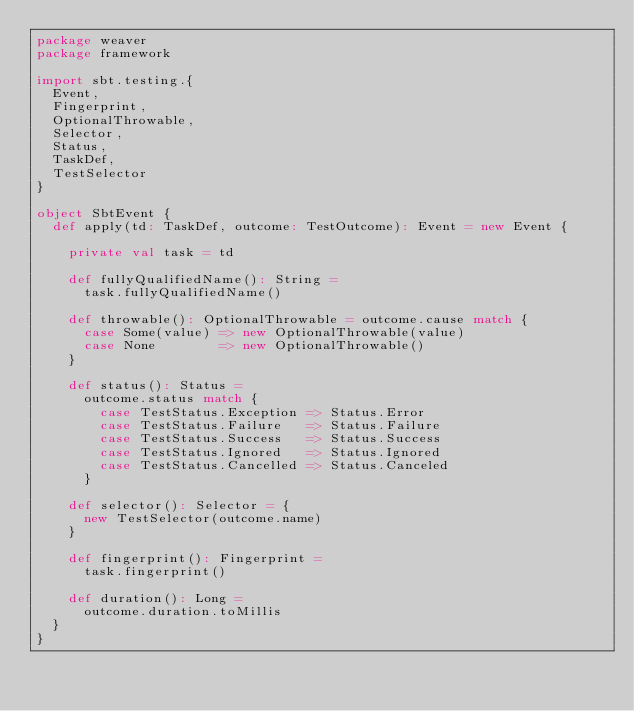<code> <loc_0><loc_0><loc_500><loc_500><_Scala_>package weaver
package framework

import sbt.testing.{
  Event,
  Fingerprint,
  OptionalThrowable,
  Selector,
  Status,
  TaskDef,
  TestSelector
}

object SbtEvent {
  def apply(td: TaskDef, outcome: TestOutcome): Event = new Event {

    private val task = td

    def fullyQualifiedName(): String =
      task.fullyQualifiedName()

    def throwable(): OptionalThrowable = outcome.cause match {
      case Some(value) => new OptionalThrowable(value)
      case None        => new OptionalThrowable()
    }

    def status(): Status =
      outcome.status match {
        case TestStatus.Exception => Status.Error
        case TestStatus.Failure   => Status.Failure
        case TestStatus.Success   => Status.Success
        case TestStatus.Ignored   => Status.Ignored
        case TestStatus.Cancelled => Status.Canceled
      }

    def selector(): Selector = {
      new TestSelector(outcome.name)
    }

    def fingerprint(): Fingerprint =
      task.fingerprint()

    def duration(): Long =
      outcome.duration.toMillis
  }
}
</code> 